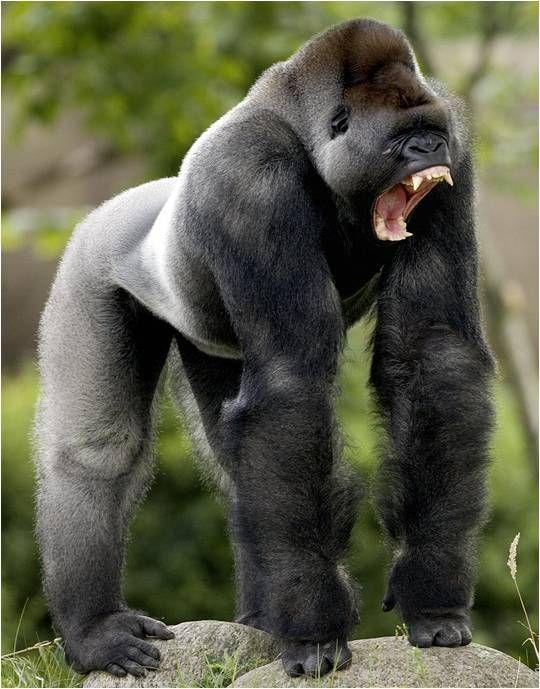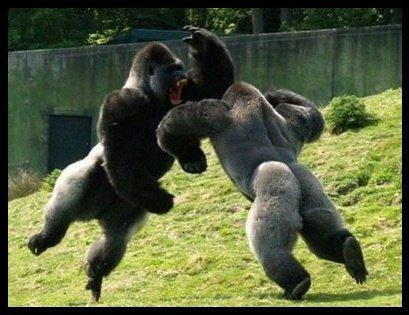The first image is the image on the left, the second image is the image on the right. Evaluate the accuracy of this statement regarding the images: "there's at least one gorilla sitting". Is it true? Answer yes or no. No. 